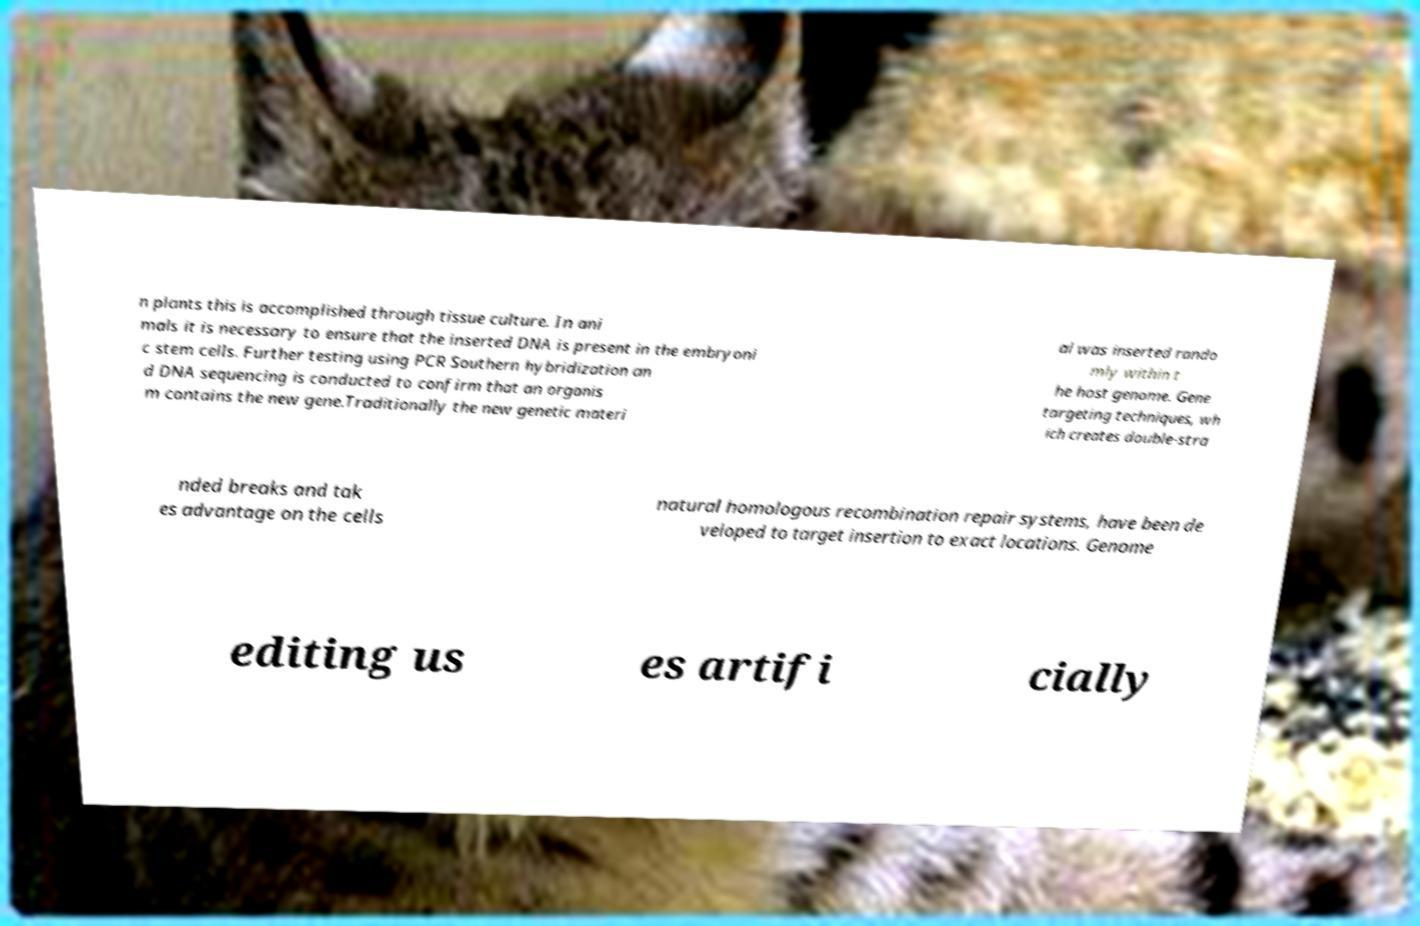Can you read and provide the text displayed in the image?This photo seems to have some interesting text. Can you extract and type it out for me? n plants this is accomplished through tissue culture. In ani mals it is necessary to ensure that the inserted DNA is present in the embryoni c stem cells. Further testing using PCR Southern hybridization an d DNA sequencing is conducted to confirm that an organis m contains the new gene.Traditionally the new genetic materi al was inserted rando mly within t he host genome. Gene targeting techniques, wh ich creates double-stra nded breaks and tak es advantage on the cells natural homologous recombination repair systems, have been de veloped to target insertion to exact locations. Genome editing us es artifi cially 